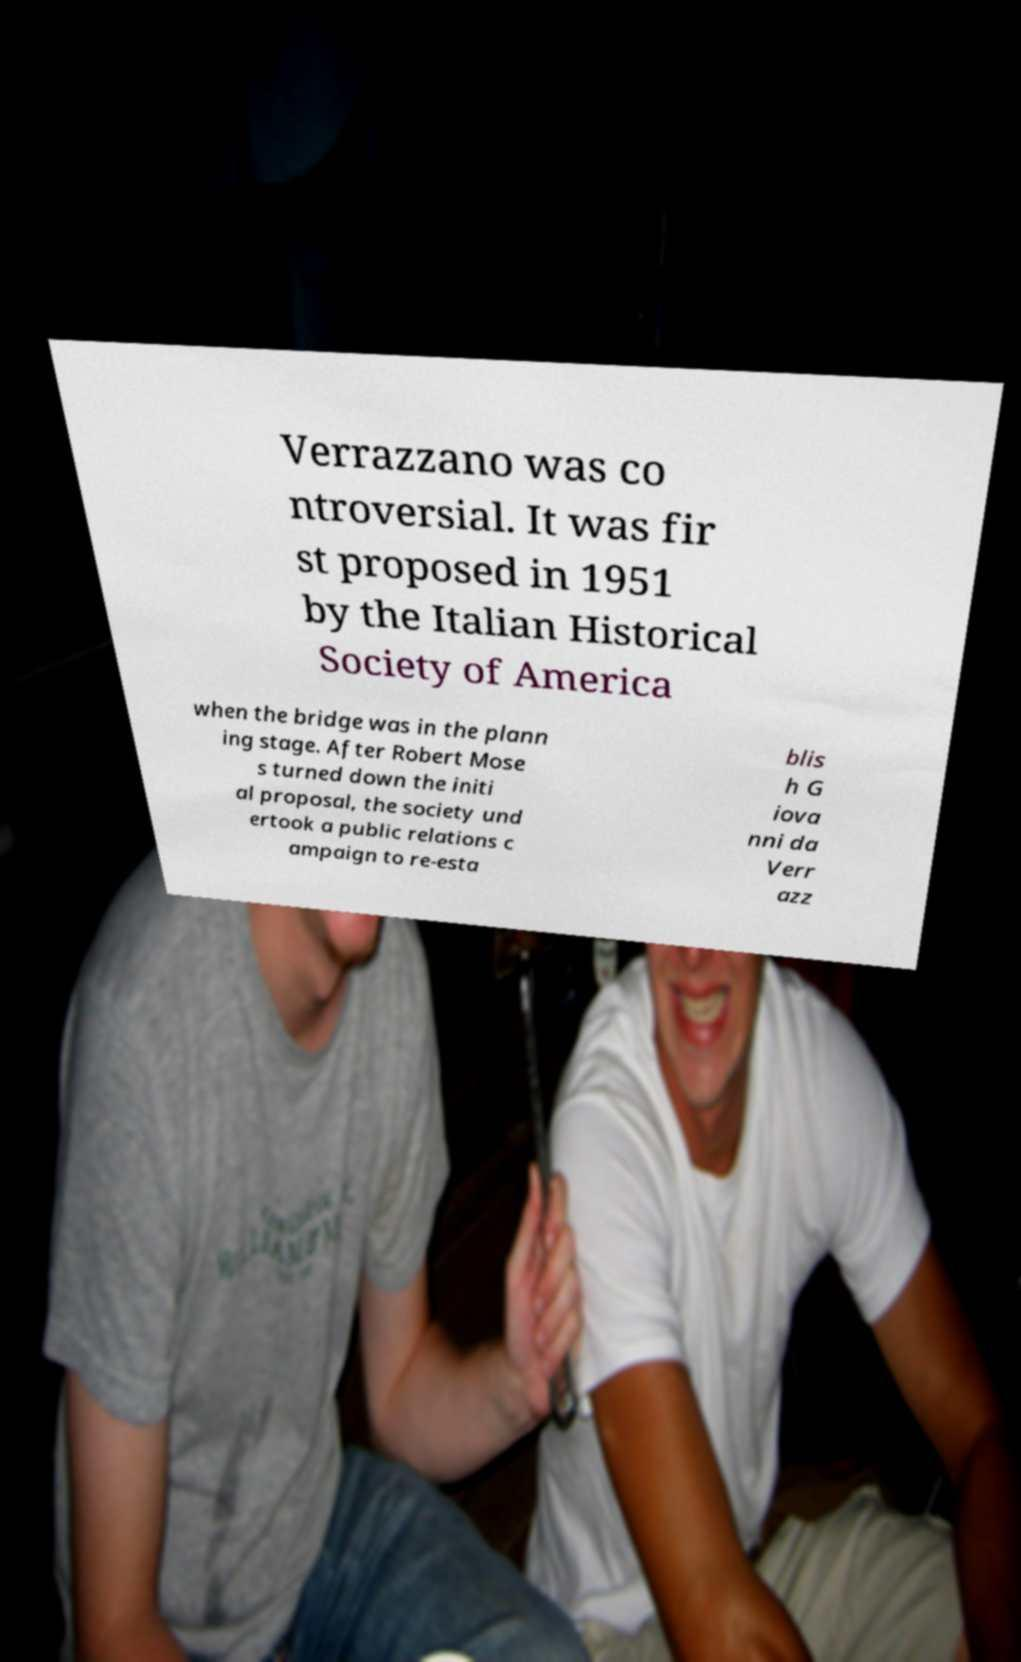Could you assist in decoding the text presented in this image and type it out clearly? Verrazzano was co ntroversial. It was fir st proposed in 1951 by the Italian Historical Society of America when the bridge was in the plann ing stage. After Robert Mose s turned down the initi al proposal, the society und ertook a public relations c ampaign to re-esta blis h G iova nni da Verr azz 